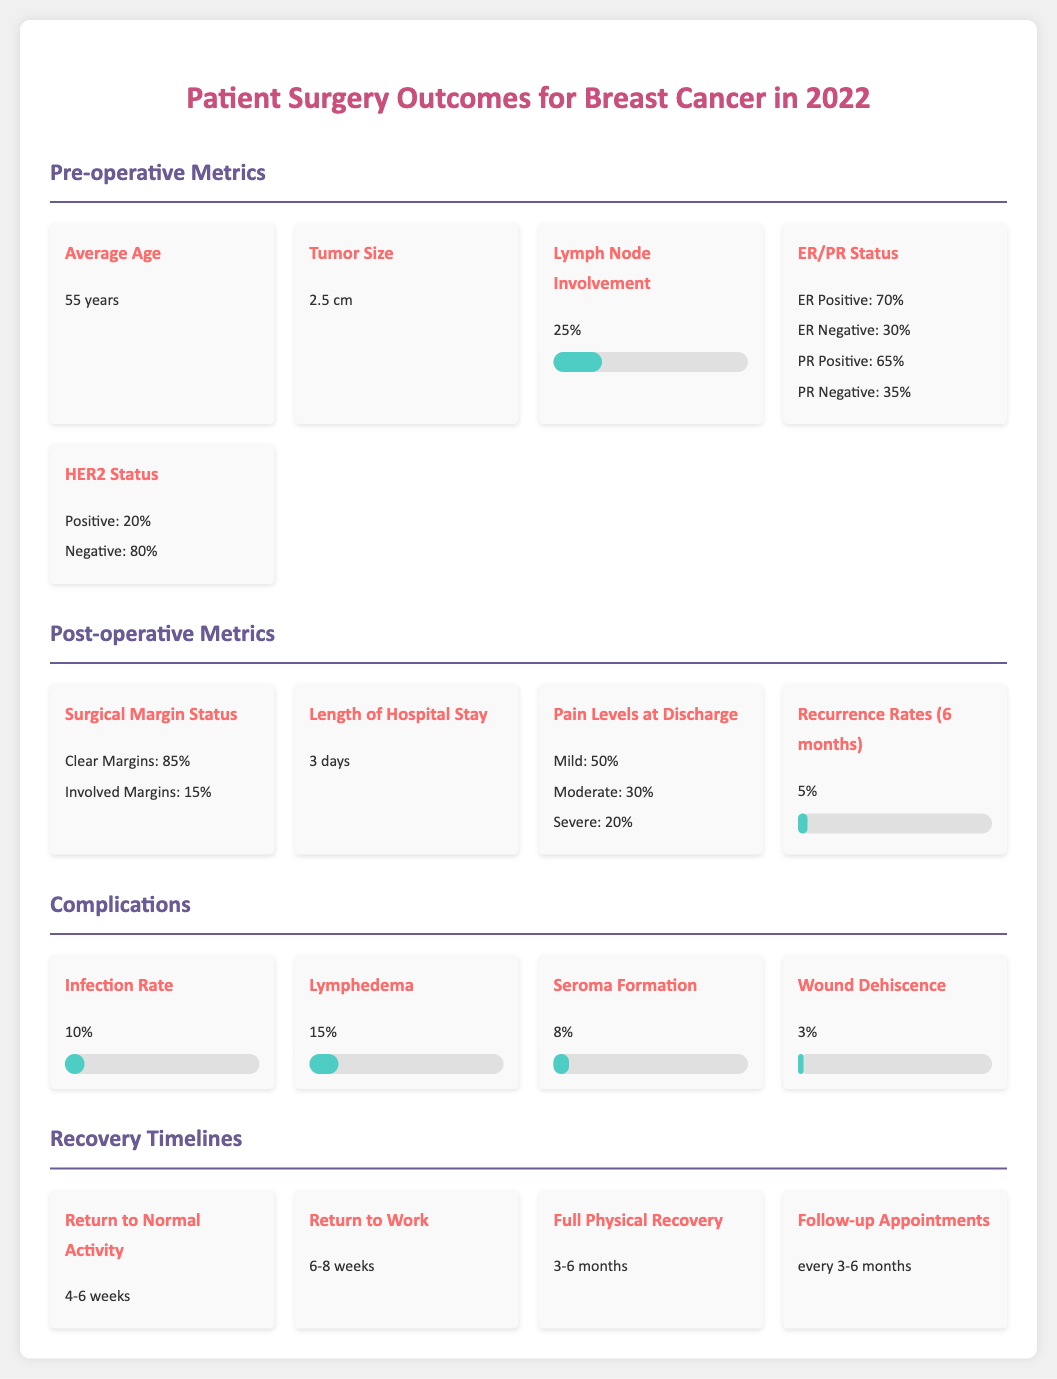What is the average age of patients? The average age is listed in the pre-operative metrics section of the document.
Answer: 55 years What percentage of patients have clear surgical margins? The percentage of clear surgical margins is stated in the post-operative metrics section.
Answer: 85% What is the infection rate post-surgery? The infection rate is provided in the complications section of the document.
Answer: 10% How long is the estimated recovery time to return to normal activity? The recovery time is specified in the recovery timelines section.
Answer: 4-6 weeks What is the percentage of patients with ER positive status? The document states the percentage related to ER status in the pre-operative metrics.
Answer: 70% What is the recurrence rate at 6 months? The recurrence rate is mentioned in the post-operative metrics section.
Answer: 5% How many days is the average length of hospital stay? The length of stay is indicated in the post-operative metrics of the document.
Answer: 3 days What is the percentage of patients that experience lymphedema? The document lists the lymphedema rate under complications.
Answer: 15% When are the follow-up appointments scheduled? The timing of follow-up appointments is detailed in the recovery timelines section.
Answer: every 3-6 months 